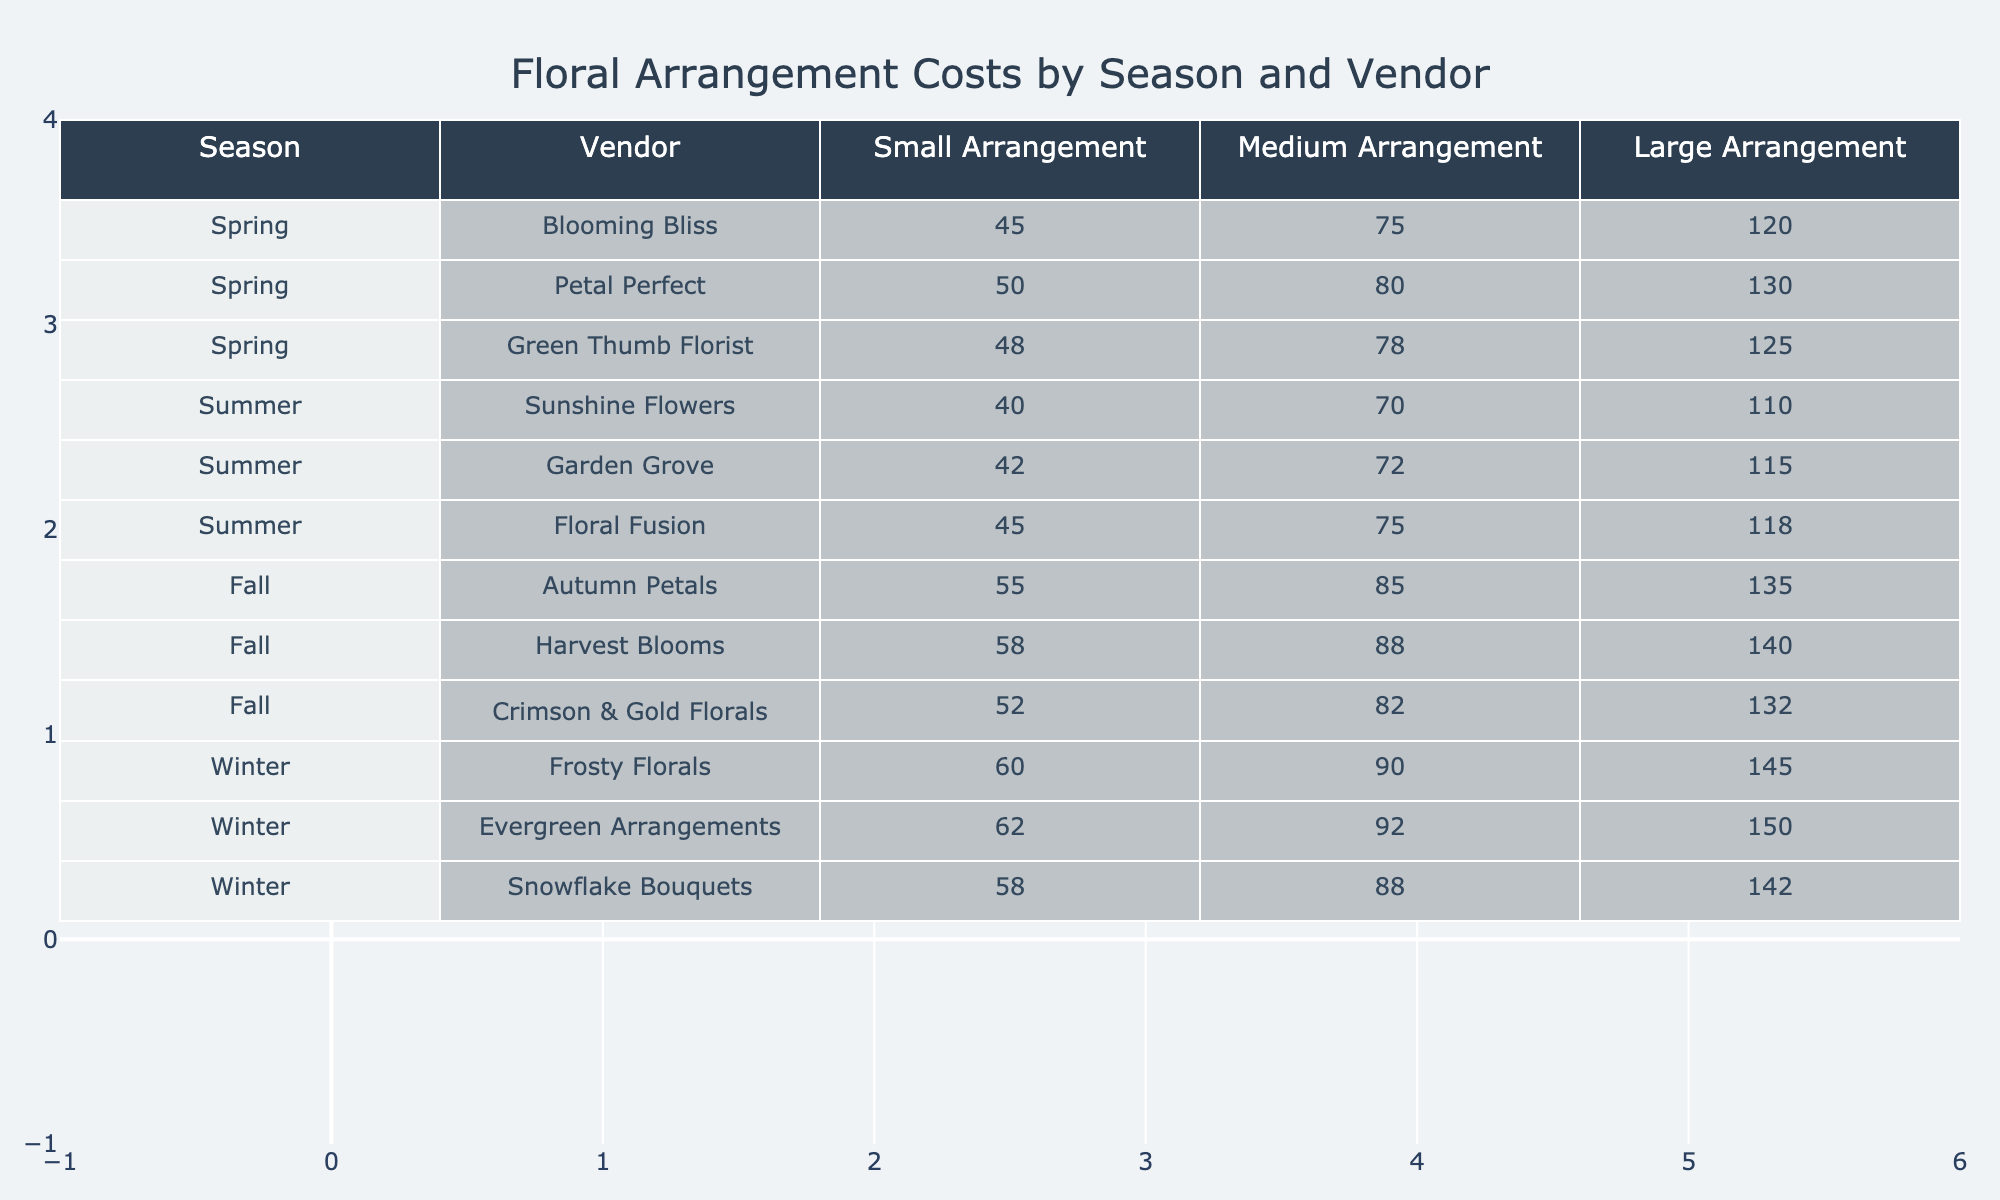What is the cost of a medium arrangement from Frosty Florals? According to the table, the cost of a medium arrangement from Frosty Florals during Winter is shown directly under the Medium Arrangement column for the Winter season. The value is 90.
Answer: 90 Which vendor offers the most expensive large arrangement in Fall? To find the most expensive large arrangement in Fall, I looked at the Large Arrangement column for the Fall season and compared the values from the three vendors. The prices are: Autumn Petals - 135, Harvest Blooms - 140, and Crimson & Gold Florals - 132. The highest value is 140 from Harvest Blooms.
Answer: Harvest Blooms What is the average cost of a small arrangement across all seasons? To calculate the average cost of a small arrangement, I summed the values from the Small Arrangement column for all vendors: (45 + 50 + 48 + 40 + 42 + 45 + 55 + 58 + 52 + 60 + 62 + 58) = 572. There are 12 arrangements, so the average is 572 / 12 = 47.67.
Answer: 47.67 Is the cost of a large arrangement from Evergreen Arrangements higher than 140? Looking at the Large Arrangement price from Evergreen Arrangements in Winter, the cost is 150. Since 150 is indeed greater than 140, the statement is true.
Answer: Yes Which season has the lowest total cost for a medium arrangement when summed across all vendors? For the medium arrangement costs: Spring (75 + 80 + 78 = 233), Summer (70 + 72 + 75 = 217), Fall (85 + 88 + 82 = 255), and Winter (90 + 92 + 88 = 270). The lowest total is for Summer, with a total of 217.
Answer: Summer 